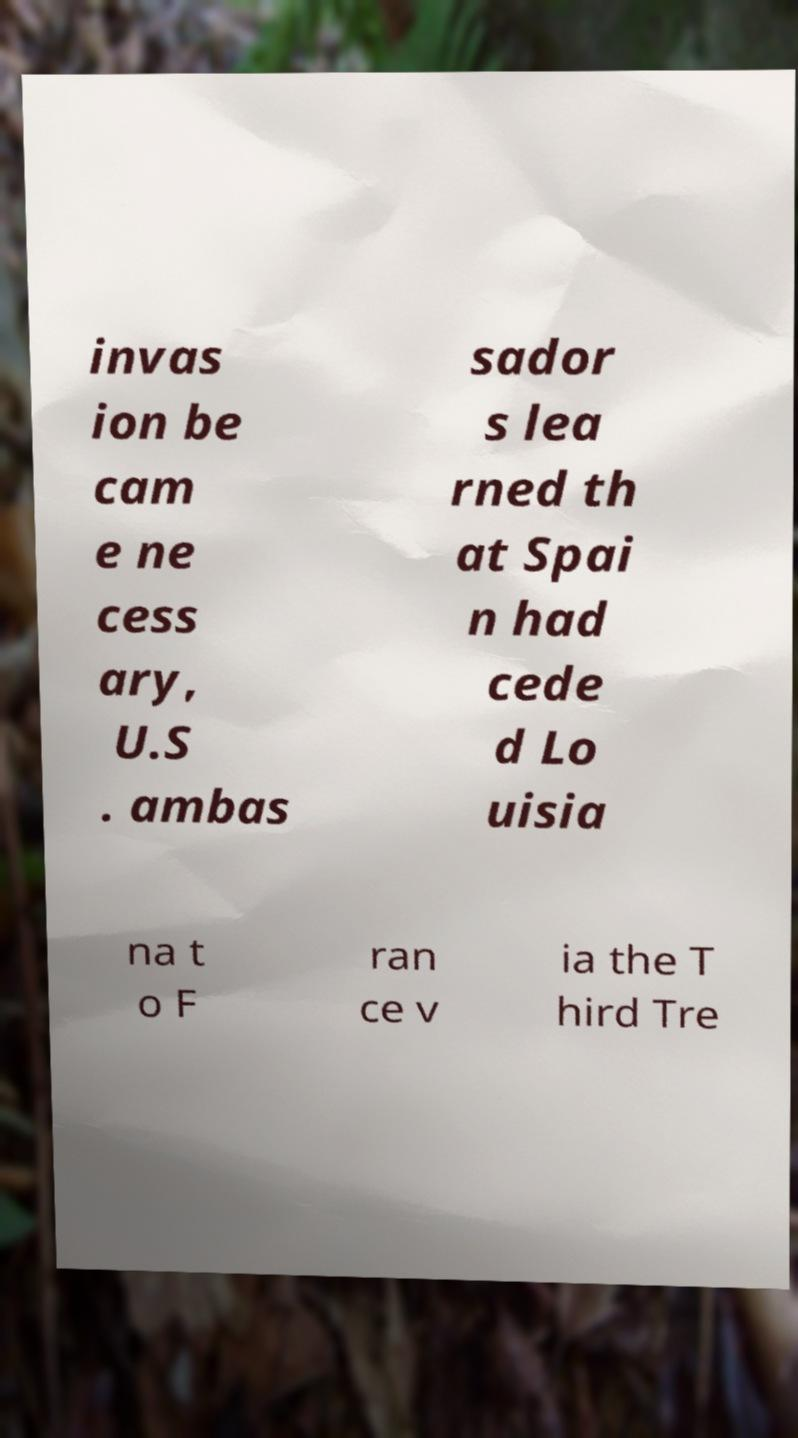Can you accurately transcribe the text from the provided image for me? invas ion be cam e ne cess ary, U.S . ambas sador s lea rned th at Spai n had cede d Lo uisia na t o F ran ce v ia the T hird Tre 